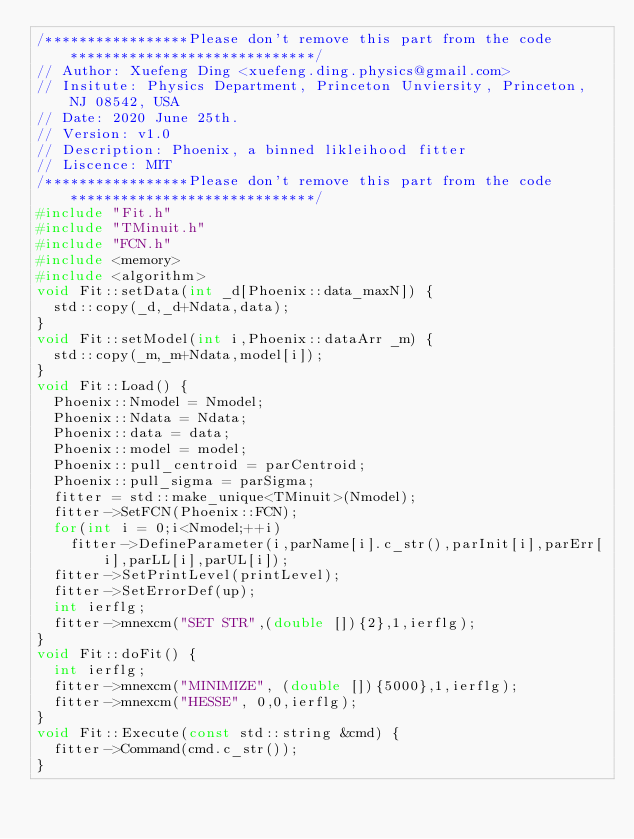<code> <loc_0><loc_0><loc_500><loc_500><_C++_>/*****************Please don't remove this part from the code*****************************/
// Author: Xuefeng Ding <xuefeng.ding.physics@gmail.com>
// Insitute: Physics Department, Princeton Unviersity, Princeton, NJ 08542, USA
// Date: 2020 June 25th.
// Version: v1.0
// Description: Phoenix, a binned likleihood fitter
// Liscence: MIT
/*****************Please don't remove this part from the code*****************************/
#include "Fit.h"
#include "TMinuit.h"
#include "FCN.h"
#include <memory>
#include <algorithm>
void Fit::setData(int _d[Phoenix::data_maxN]) {
  std::copy(_d,_d+Ndata,data);
}
void Fit::setModel(int i,Phoenix::dataArr _m) {
  std::copy(_m,_m+Ndata,model[i]);
}
void Fit::Load() {
  Phoenix::Nmodel = Nmodel;
  Phoenix::Ndata = Ndata;
  Phoenix::data = data;
  Phoenix::model = model;
  Phoenix::pull_centroid = parCentroid;
  Phoenix::pull_sigma = parSigma;
  fitter = std::make_unique<TMinuit>(Nmodel);
  fitter->SetFCN(Phoenix::FCN);
  for(int i = 0;i<Nmodel;++i)
    fitter->DefineParameter(i,parName[i].c_str(),parInit[i],parErr[i],parLL[i],parUL[i]);
  fitter->SetPrintLevel(printLevel);
  fitter->SetErrorDef(up);
  int ierflg;
  fitter->mnexcm("SET STR",(double []){2},1,ierflg);
}
void Fit::doFit() {
  int ierflg;
  fitter->mnexcm("MINIMIZE", (double []){5000},1,ierflg);
  fitter->mnexcm("HESSE", 0,0,ierflg);
}
void Fit::Execute(const std::string &cmd) {
  fitter->Command(cmd.c_str());
}
</code> 